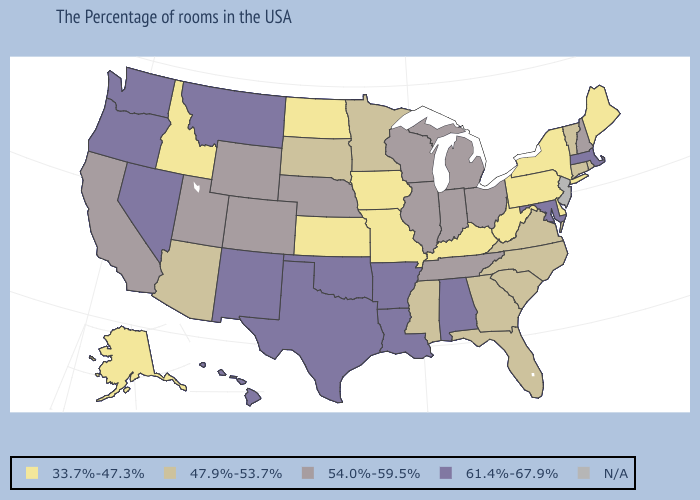What is the lowest value in the Northeast?
Concise answer only. 33.7%-47.3%. Name the states that have a value in the range N/A?
Give a very brief answer. New Jersey. Is the legend a continuous bar?
Quick response, please. No. Name the states that have a value in the range N/A?
Write a very short answer. New Jersey. What is the value of Iowa?
Keep it brief. 33.7%-47.3%. Name the states that have a value in the range 54.0%-59.5%?
Keep it brief. New Hampshire, Ohio, Michigan, Indiana, Tennessee, Wisconsin, Illinois, Nebraska, Wyoming, Colorado, Utah, California. What is the highest value in states that border New Hampshire?
Concise answer only. 61.4%-67.9%. Name the states that have a value in the range 54.0%-59.5%?
Be succinct. New Hampshire, Ohio, Michigan, Indiana, Tennessee, Wisconsin, Illinois, Nebraska, Wyoming, Colorado, Utah, California. What is the value of Mississippi?
Be succinct. 47.9%-53.7%. Does Georgia have the highest value in the USA?
Quick response, please. No. Does the first symbol in the legend represent the smallest category?
Give a very brief answer. Yes. Name the states that have a value in the range 47.9%-53.7%?
Give a very brief answer. Rhode Island, Vermont, Connecticut, Virginia, North Carolina, South Carolina, Florida, Georgia, Mississippi, Minnesota, South Dakota, Arizona. Among the states that border Wyoming , which have the highest value?
Answer briefly. Montana. Among the states that border South Dakota , which have the lowest value?
Answer briefly. Iowa, North Dakota. How many symbols are there in the legend?
Write a very short answer. 5. 